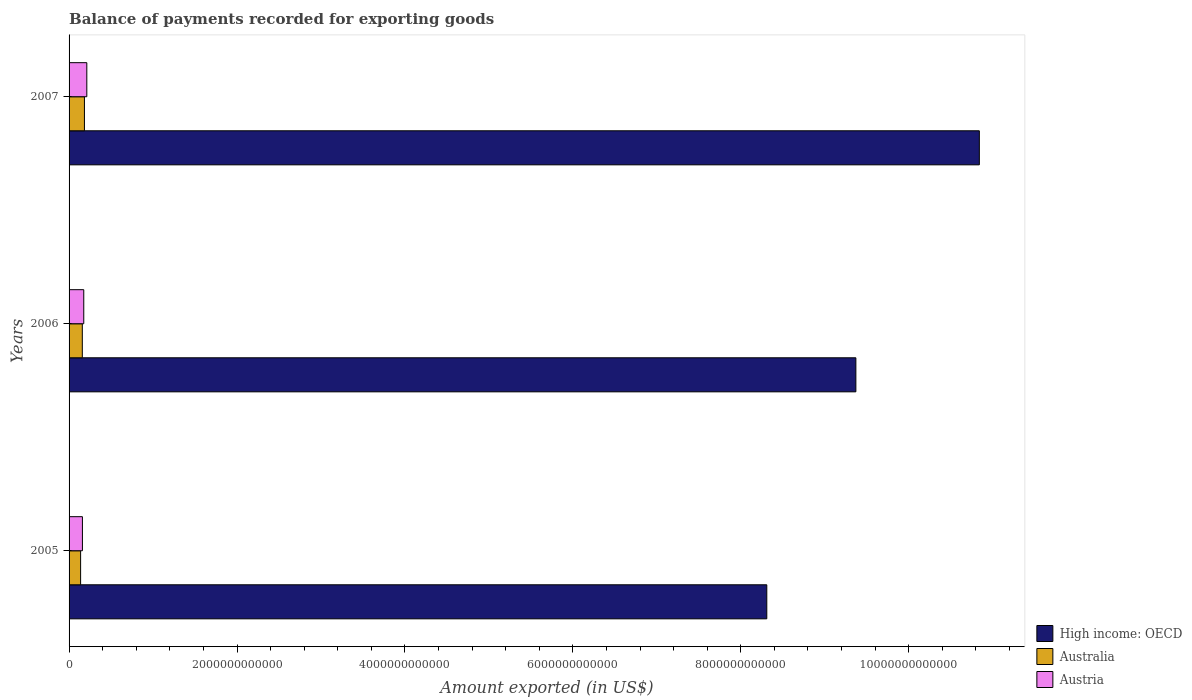How many groups of bars are there?
Your answer should be very brief. 3. Are the number of bars on each tick of the Y-axis equal?
Your answer should be compact. Yes. How many bars are there on the 3rd tick from the top?
Ensure brevity in your answer.  3. How many bars are there on the 2nd tick from the bottom?
Keep it short and to the point. 3. What is the amount exported in Austria in 2005?
Your answer should be very brief. 1.59e+11. Across all years, what is the maximum amount exported in Austria?
Keep it short and to the point. 2.11e+11. Across all years, what is the minimum amount exported in Austria?
Provide a short and direct response. 1.59e+11. In which year was the amount exported in High income: OECD maximum?
Give a very brief answer. 2007. What is the total amount exported in High income: OECD in the graph?
Give a very brief answer. 2.85e+13. What is the difference between the amount exported in Australia in 2005 and that in 2007?
Give a very brief answer. -4.55e+1. What is the difference between the amount exported in Australia in 2006 and the amount exported in High income: OECD in 2007?
Your answer should be compact. -1.07e+13. What is the average amount exported in High income: OECD per year?
Ensure brevity in your answer.  9.51e+12. In the year 2006, what is the difference between the amount exported in Austria and amount exported in High income: OECD?
Give a very brief answer. -9.20e+12. What is the ratio of the amount exported in Austria in 2005 to that in 2006?
Offer a very short reply. 0.91. Is the amount exported in Australia in 2005 less than that in 2006?
Offer a terse response. Yes. Is the difference between the amount exported in Austria in 2005 and 2007 greater than the difference between the amount exported in High income: OECD in 2005 and 2007?
Ensure brevity in your answer.  Yes. What is the difference between the highest and the second highest amount exported in Austria?
Offer a terse response. 3.63e+1. What is the difference between the highest and the lowest amount exported in Australia?
Ensure brevity in your answer.  4.55e+1. Is the sum of the amount exported in Australia in 2006 and 2007 greater than the maximum amount exported in High income: OECD across all years?
Provide a succinct answer. No. What does the 3rd bar from the top in 2005 represents?
Offer a very short reply. High income: OECD. What does the 1st bar from the bottom in 2006 represents?
Make the answer very short. High income: OECD. What is the difference between two consecutive major ticks on the X-axis?
Make the answer very short. 2.00e+12. Are the values on the major ticks of X-axis written in scientific E-notation?
Give a very brief answer. No. Does the graph contain any zero values?
Your answer should be compact. No. What is the title of the graph?
Ensure brevity in your answer.  Balance of payments recorded for exporting goods. What is the label or title of the X-axis?
Offer a very short reply. Amount exported (in US$). What is the Amount exported (in US$) of High income: OECD in 2005?
Provide a short and direct response. 8.31e+12. What is the Amount exported (in US$) of Australia in 2005?
Offer a very short reply. 1.37e+11. What is the Amount exported (in US$) in Austria in 2005?
Make the answer very short. 1.59e+11. What is the Amount exported (in US$) of High income: OECD in 2006?
Provide a succinct answer. 9.37e+12. What is the Amount exported (in US$) of Australia in 2006?
Ensure brevity in your answer.  1.58e+11. What is the Amount exported (in US$) of Austria in 2006?
Provide a succinct answer. 1.75e+11. What is the Amount exported (in US$) in High income: OECD in 2007?
Your answer should be very brief. 1.08e+13. What is the Amount exported (in US$) in Australia in 2007?
Your response must be concise. 1.83e+11. What is the Amount exported (in US$) in Austria in 2007?
Provide a short and direct response. 2.11e+11. Across all years, what is the maximum Amount exported (in US$) in High income: OECD?
Provide a short and direct response. 1.08e+13. Across all years, what is the maximum Amount exported (in US$) in Australia?
Offer a very short reply. 1.83e+11. Across all years, what is the maximum Amount exported (in US$) in Austria?
Ensure brevity in your answer.  2.11e+11. Across all years, what is the minimum Amount exported (in US$) in High income: OECD?
Make the answer very short. 8.31e+12. Across all years, what is the minimum Amount exported (in US$) in Australia?
Your answer should be very brief. 1.37e+11. Across all years, what is the minimum Amount exported (in US$) in Austria?
Offer a terse response. 1.59e+11. What is the total Amount exported (in US$) in High income: OECD in the graph?
Provide a short and direct response. 2.85e+13. What is the total Amount exported (in US$) of Australia in the graph?
Your answer should be very brief. 4.78e+11. What is the total Amount exported (in US$) in Austria in the graph?
Offer a terse response. 5.45e+11. What is the difference between the Amount exported (in US$) in High income: OECD in 2005 and that in 2006?
Your answer should be very brief. -1.06e+12. What is the difference between the Amount exported (in US$) in Australia in 2005 and that in 2006?
Keep it short and to the point. -2.03e+1. What is the difference between the Amount exported (in US$) in Austria in 2005 and that in 2006?
Ensure brevity in your answer.  -1.60e+1. What is the difference between the Amount exported (in US$) of High income: OECD in 2005 and that in 2007?
Your response must be concise. -2.53e+12. What is the difference between the Amount exported (in US$) in Australia in 2005 and that in 2007?
Your answer should be compact. -4.55e+1. What is the difference between the Amount exported (in US$) of Austria in 2005 and that in 2007?
Provide a succinct answer. -5.23e+1. What is the difference between the Amount exported (in US$) of High income: OECD in 2006 and that in 2007?
Provide a short and direct response. -1.47e+12. What is the difference between the Amount exported (in US$) of Australia in 2006 and that in 2007?
Offer a very short reply. -2.52e+1. What is the difference between the Amount exported (in US$) in Austria in 2006 and that in 2007?
Keep it short and to the point. -3.63e+1. What is the difference between the Amount exported (in US$) of High income: OECD in 2005 and the Amount exported (in US$) of Australia in 2006?
Provide a short and direct response. 8.15e+12. What is the difference between the Amount exported (in US$) of High income: OECD in 2005 and the Amount exported (in US$) of Austria in 2006?
Your response must be concise. 8.13e+12. What is the difference between the Amount exported (in US$) of Australia in 2005 and the Amount exported (in US$) of Austria in 2006?
Your answer should be compact. -3.76e+1. What is the difference between the Amount exported (in US$) of High income: OECD in 2005 and the Amount exported (in US$) of Australia in 2007?
Make the answer very short. 8.13e+12. What is the difference between the Amount exported (in US$) of High income: OECD in 2005 and the Amount exported (in US$) of Austria in 2007?
Your response must be concise. 8.10e+12. What is the difference between the Amount exported (in US$) in Australia in 2005 and the Amount exported (in US$) in Austria in 2007?
Provide a short and direct response. -7.39e+1. What is the difference between the Amount exported (in US$) of High income: OECD in 2006 and the Amount exported (in US$) of Australia in 2007?
Your response must be concise. 9.19e+12. What is the difference between the Amount exported (in US$) of High income: OECD in 2006 and the Amount exported (in US$) of Austria in 2007?
Make the answer very short. 9.16e+12. What is the difference between the Amount exported (in US$) of Australia in 2006 and the Amount exported (in US$) of Austria in 2007?
Offer a very short reply. -5.36e+1. What is the average Amount exported (in US$) of High income: OECD per year?
Your answer should be very brief. 9.51e+12. What is the average Amount exported (in US$) of Australia per year?
Your response must be concise. 1.59e+11. What is the average Amount exported (in US$) in Austria per year?
Offer a terse response. 1.82e+11. In the year 2005, what is the difference between the Amount exported (in US$) of High income: OECD and Amount exported (in US$) of Australia?
Provide a succinct answer. 8.17e+12. In the year 2005, what is the difference between the Amount exported (in US$) of High income: OECD and Amount exported (in US$) of Austria?
Ensure brevity in your answer.  8.15e+12. In the year 2005, what is the difference between the Amount exported (in US$) of Australia and Amount exported (in US$) of Austria?
Provide a short and direct response. -2.16e+1. In the year 2006, what is the difference between the Amount exported (in US$) of High income: OECD and Amount exported (in US$) of Australia?
Keep it short and to the point. 9.21e+12. In the year 2006, what is the difference between the Amount exported (in US$) in High income: OECD and Amount exported (in US$) in Austria?
Offer a terse response. 9.20e+12. In the year 2006, what is the difference between the Amount exported (in US$) in Australia and Amount exported (in US$) in Austria?
Give a very brief answer. -1.73e+1. In the year 2007, what is the difference between the Amount exported (in US$) in High income: OECD and Amount exported (in US$) in Australia?
Provide a short and direct response. 1.07e+13. In the year 2007, what is the difference between the Amount exported (in US$) of High income: OECD and Amount exported (in US$) of Austria?
Make the answer very short. 1.06e+13. In the year 2007, what is the difference between the Amount exported (in US$) in Australia and Amount exported (in US$) in Austria?
Your answer should be compact. -2.83e+1. What is the ratio of the Amount exported (in US$) in High income: OECD in 2005 to that in 2006?
Provide a short and direct response. 0.89. What is the ratio of the Amount exported (in US$) of Australia in 2005 to that in 2006?
Offer a very short reply. 0.87. What is the ratio of the Amount exported (in US$) of Austria in 2005 to that in 2006?
Ensure brevity in your answer.  0.91. What is the ratio of the Amount exported (in US$) in High income: OECD in 2005 to that in 2007?
Ensure brevity in your answer.  0.77. What is the ratio of the Amount exported (in US$) in Australia in 2005 to that in 2007?
Offer a terse response. 0.75. What is the ratio of the Amount exported (in US$) of Austria in 2005 to that in 2007?
Offer a terse response. 0.75. What is the ratio of the Amount exported (in US$) in High income: OECD in 2006 to that in 2007?
Provide a short and direct response. 0.86. What is the ratio of the Amount exported (in US$) of Australia in 2006 to that in 2007?
Provide a short and direct response. 0.86. What is the ratio of the Amount exported (in US$) in Austria in 2006 to that in 2007?
Offer a very short reply. 0.83. What is the difference between the highest and the second highest Amount exported (in US$) in High income: OECD?
Offer a terse response. 1.47e+12. What is the difference between the highest and the second highest Amount exported (in US$) of Australia?
Offer a very short reply. 2.52e+1. What is the difference between the highest and the second highest Amount exported (in US$) in Austria?
Make the answer very short. 3.63e+1. What is the difference between the highest and the lowest Amount exported (in US$) in High income: OECD?
Offer a very short reply. 2.53e+12. What is the difference between the highest and the lowest Amount exported (in US$) in Australia?
Provide a short and direct response. 4.55e+1. What is the difference between the highest and the lowest Amount exported (in US$) of Austria?
Make the answer very short. 5.23e+1. 